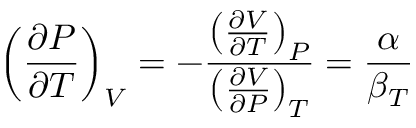<formula> <loc_0><loc_0><loc_500><loc_500>\left ( { \frac { \partial P } { \partial T } } \right ) _ { V } = - { \frac { \left ( { \frac { \partial V } { \partial T } } \right ) _ { P } } { \left ( { \frac { \partial V } { \partial P } } \right ) _ { T } } } = { \frac { \alpha } { \beta _ { T } } }</formula> 